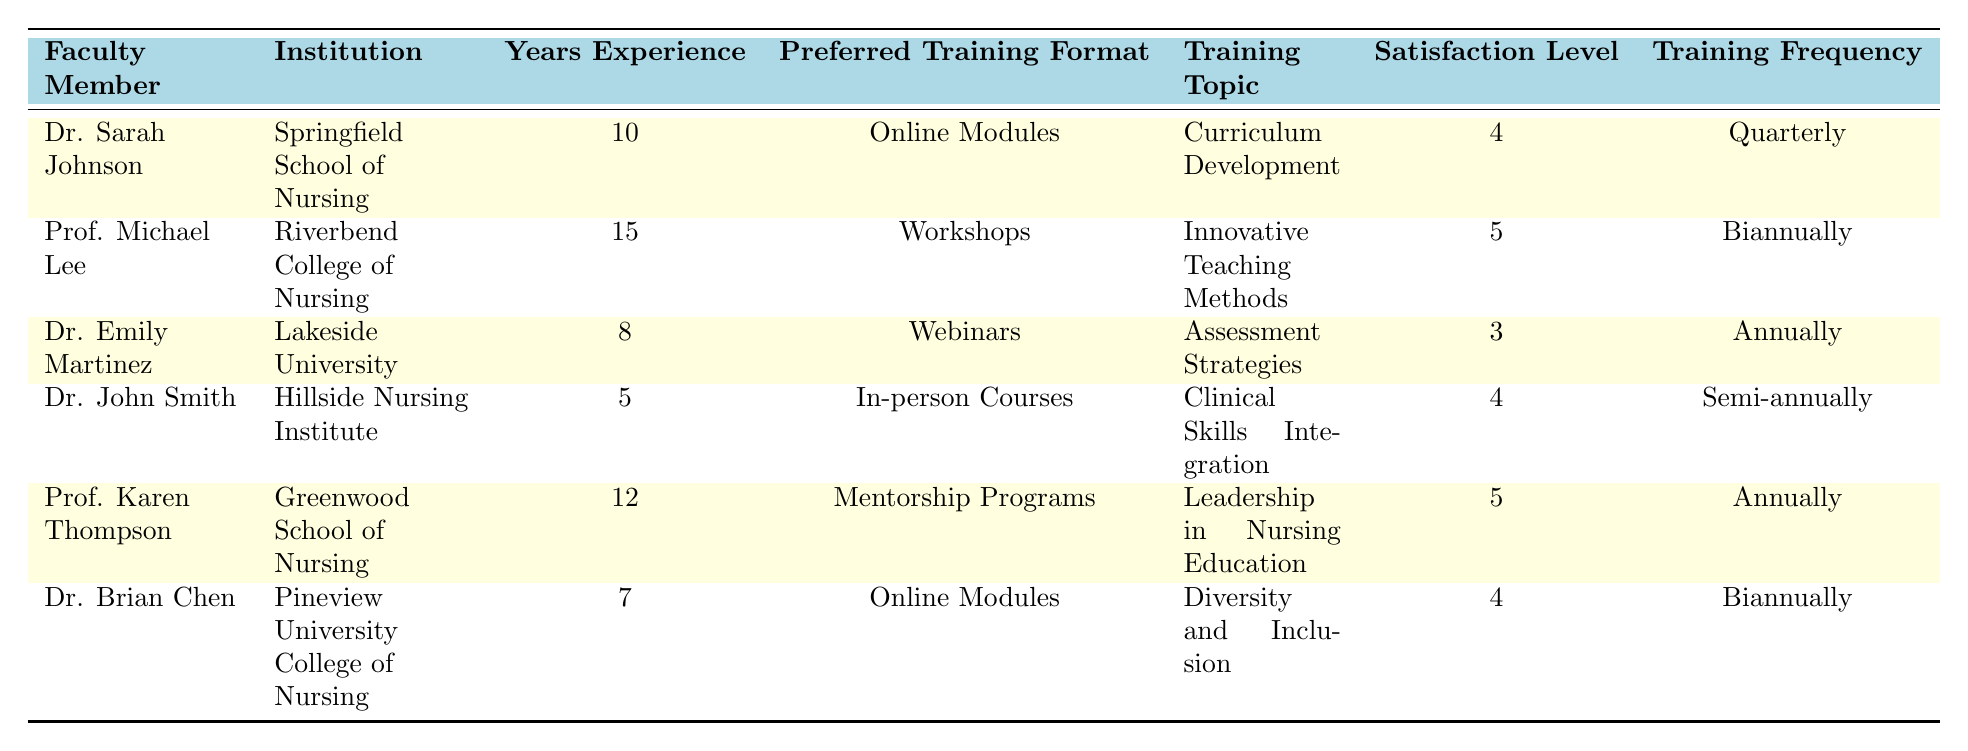What is the preferred training format of Dr. Emily Martinez? According to the table, Dr. Emily Martinez's preferred training format is "Webinars."
Answer: Webinars Which faculty member has the highest satisfaction level? The highest satisfaction level in the table is 5, which is shared by Prof. Michael Lee and Prof. Karen Thompson.
Answer: Prof. Michael Lee and Prof. Karen Thompson What is the average years of experience of the faculty members in the table? To find the average years of experience, sum the years (10 + 15 + 8 + 5 + 12 + 7 = 57) and divide by the number of faculty members (6). Therefore, the average is 57/6 = 9.5.
Answer: 9.5 Does Dr. John Smith prefer online training formats? Looking at the table, Dr. John Smith prefers "In-person Courses," so he does not prefer an online format.
Answer: No What is the satisfaction level of faculty members who prefer Online Modules? From the table, two faculty members prefer Online Modules: Dr. Sarah Johnson with a satisfaction level of 4 and Dr. Brian Chen with a satisfaction level of 4. Therefore, the average satisfaction level is (4+4)/2 = 4.
Answer: 4 Which training frequency is most common among the faculty members? Analyzing the table, the frequencies are: Quarterly (1), Biannually (2), Annually (2), and Semi-annually (1). Biannually and Annually are both the most common, with 2 occurrences each.
Answer: Biannually and Annually What is the training topic preferred by Dr. Sarah Johnson? The table shows that Dr. Sarah Johnson's preferred training topic is "Curriculum Development."
Answer: Curriculum Development Is there any faculty member with less than 5 years of experience? Reviewing the table, the faculty member with the least experience is Dr. John Smith, who has 5 years of experience. Therefore, there are no faculty members with less than 5 years experience.
Answer: No 